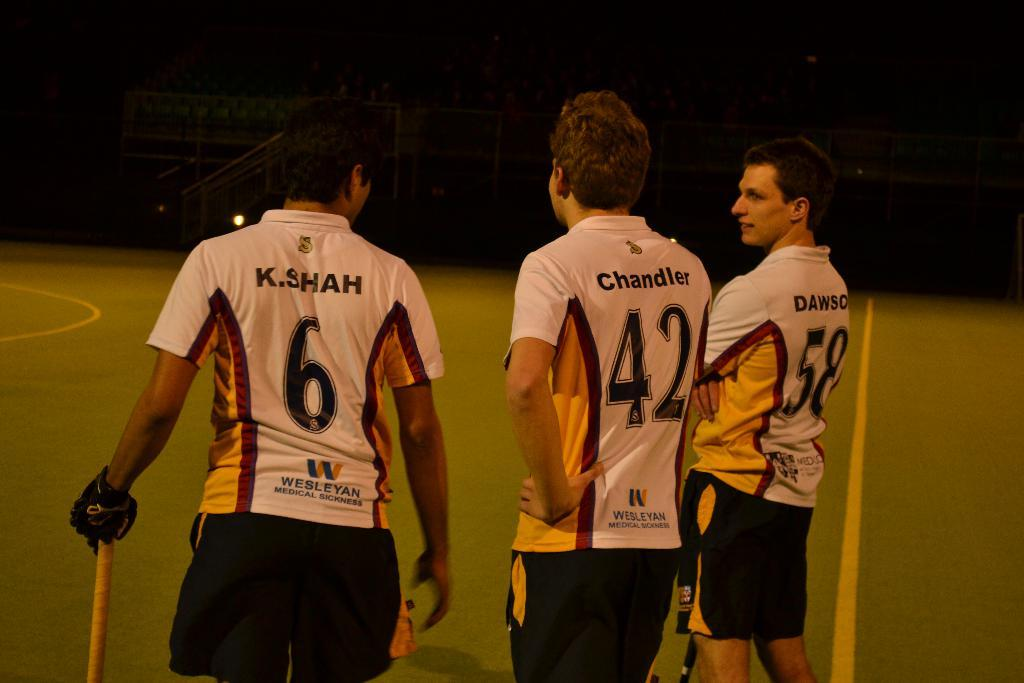<image>
Describe the image concisely. The sponsor for the the men athletes is Wesleyan Medical Sickness. 